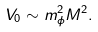<formula> <loc_0><loc_0><loc_500><loc_500>V _ { 0 } \sim m _ { \phi } ^ { 2 } M ^ { 2 } .</formula> 